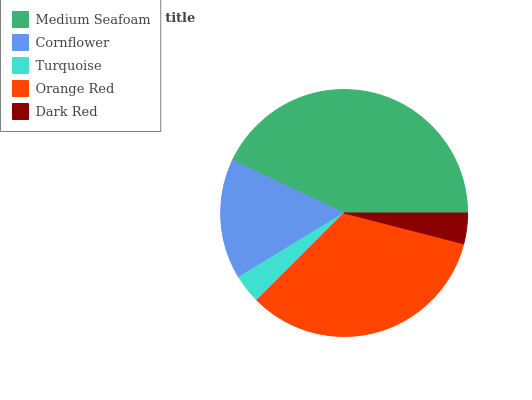Is Turquoise the minimum?
Answer yes or no. Yes. Is Medium Seafoam the maximum?
Answer yes or no. Yes. Is Cornflower the minimum?
Answer yes or no. No. Is Cornflower the maximum?
Answer yes or no. No. Is Medium Seafoam greater than Cornflower?
Answer yes or no. Yes. Is Cornflower less than Medium Seafoam?
Answer yes or no. Yes. Is Cornflower greater than Medium Seafoam?
Answer yes or no. No. Is Medium Seafoam less than Cornflower?
Answer yes or no. No. Is Cornflower the high median?
Answer yes or no. Yes. Is Cornflower the low median?
Answer yes or no. Yes. Is Dark Red the high median?
Answer yes or no. No. Is Turquoise the low median?
Answer yes or no. No. 